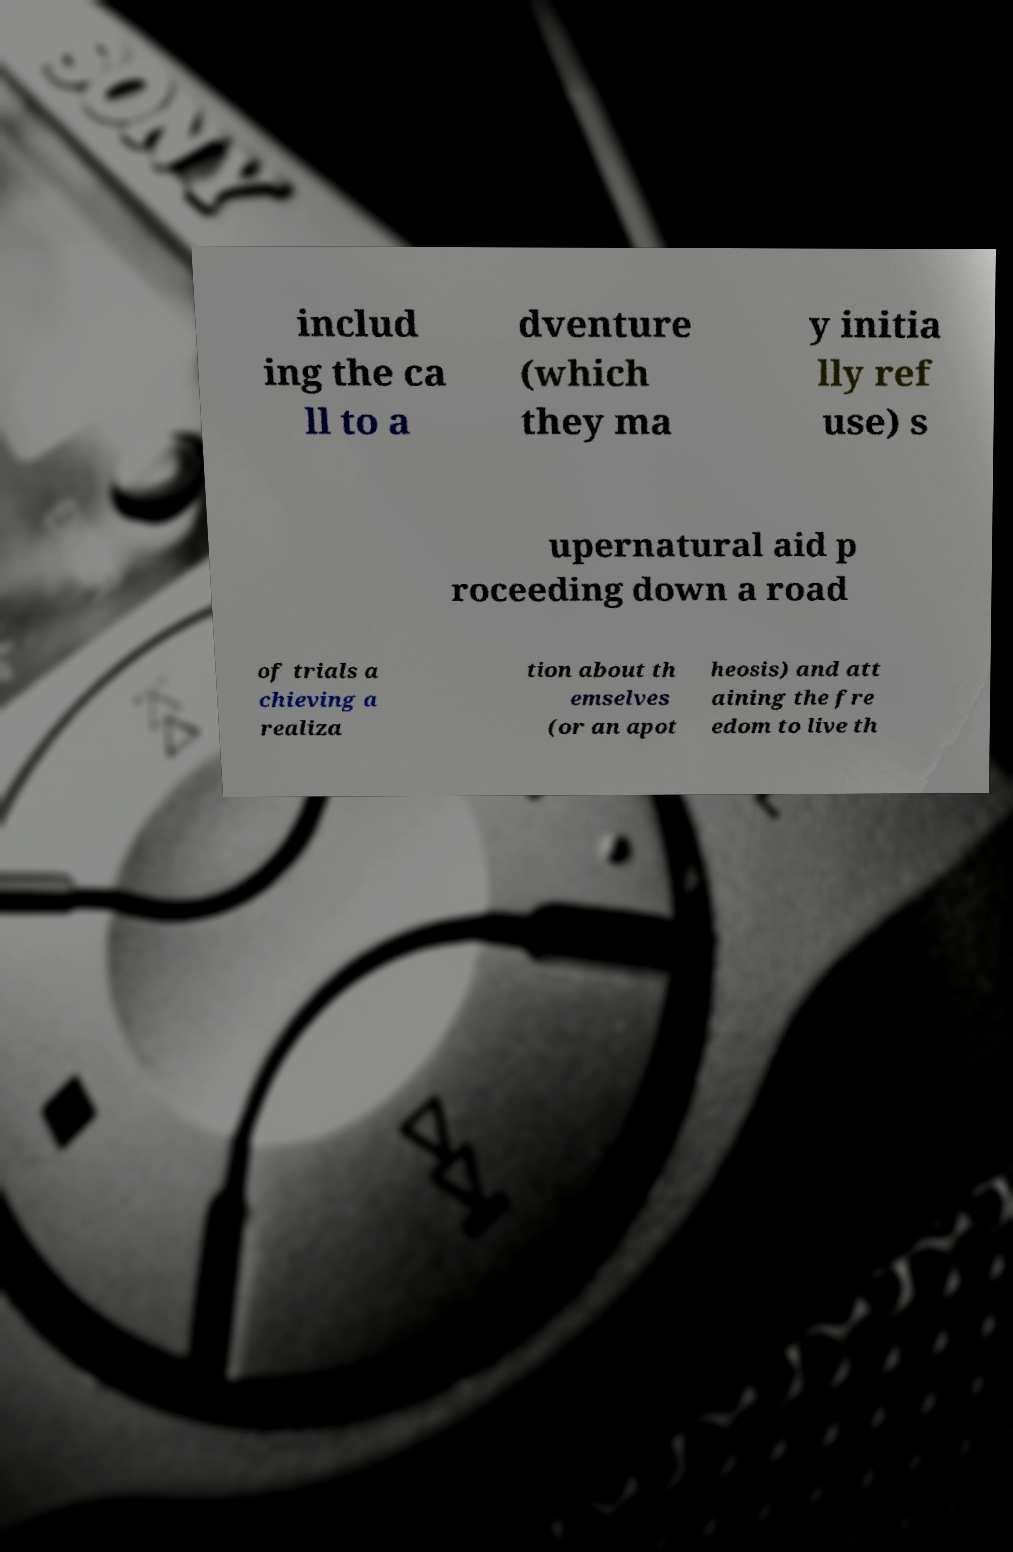For documentation purposes, I need the text within this image transcribed. Could you provide that? includ ing the ca ll to a dventure (which they ma y initia lly ref use) s upernatural aid p roceeding down a road of trials a chieving a realiza tion about th emselves (or an apot heosis) and att aining the fre edom to live th 